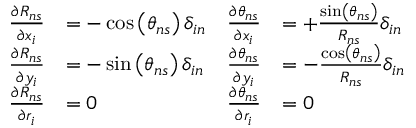<formula> <loc_0><loc_0><loc_500><loc_500>{ \begin{array} { r l r l } { \frac { \partial R _ { n s } } { \partial x _ { i } } } & { = - \cos \left ( \theta _ { n s } \right ) \delta _ { i n } } & { \frac { \partial \theta _ { n s } } { \partial x _ { i } } } & { = + \frac { \sin \left ( \theta _ { n s } \right ) } { R _ { n s } } \delta _ { i n } } \\ { \frac { \partial R _ { n s } } { \partial y _ { i } } } & { = - \sin \left ( \theta _ { n s } \right ) \delta _ { i n } } & { \frac { \partial \theta _ { n s } } { \partial y _ { i } } } & { = - \frac { \cos \left ( \theta _ { n s } \right ) } { R _ { n s } } \delta _ { i n } } \\ { \frac { \partial R _ { n s } } { \partial r _ { i } } } & { = 0 } & { \frac { \partial \theta _ { n s } } { \partial r _ { i } } } & { = 0 } \end{array} }</formula> 